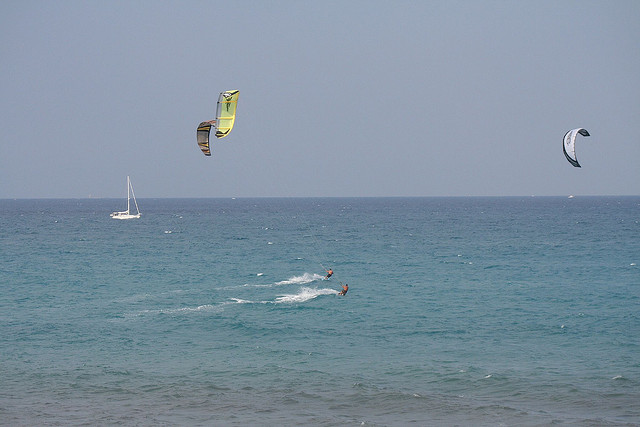Are there any notable color contrasts or patterns in the image? Yes, the parasails have distinct colors that contrast nicely with the blue of the ocean and sky. One parasail is predominantly yellow, while the others feature a mix of vibrant colors that stand out against the seascape. 